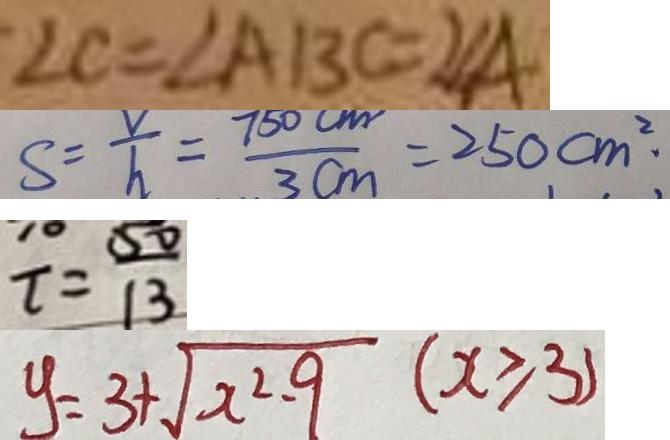Convert formula to latex. <formula><loc_0><loc_0><loc_500><loc_500>\angle C = \angle A B C = 2 \angle A 
 S = \frac { V } { h } = \frac { 7 5 0 c m } { 3 c m } = 2 5 0 c m ^ { 2 } \cdot 
 t = \frac { 5 0 } { 1 3 } 
 y = 3 + \sqrt { x ^ { 2 } - 9 } ( x \geq 3 )</formula> 